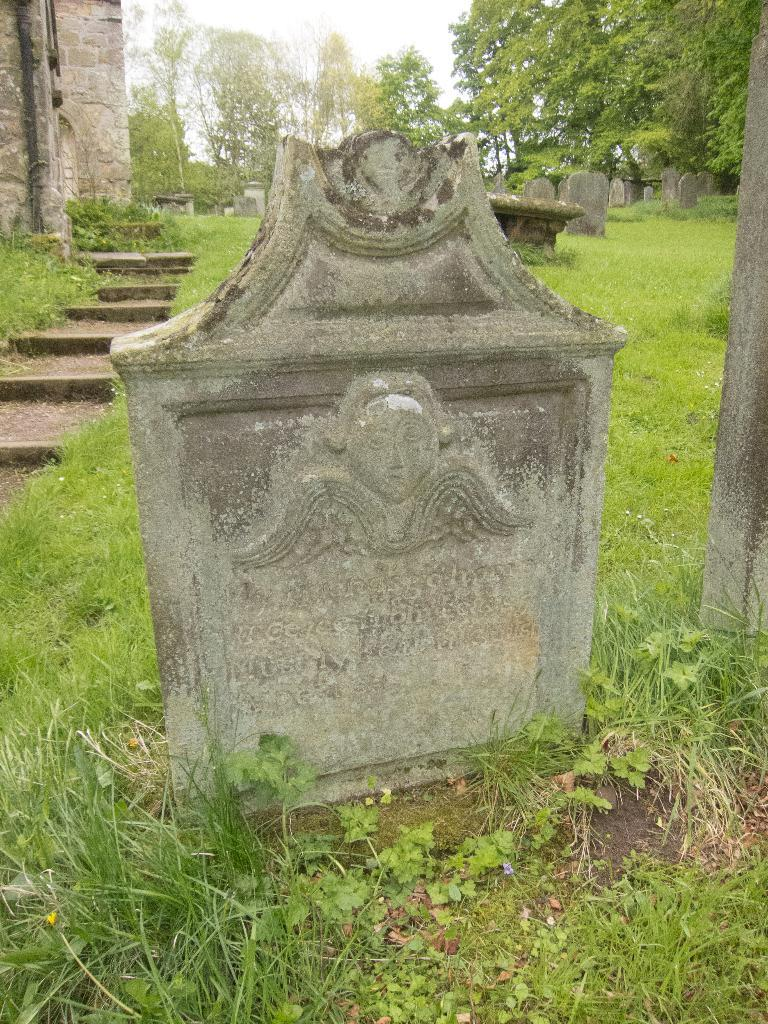What type of location is depicted in the image? The image contains cemeteries, which suggests a solemn or memorial location. What type of vegetation can be seen in the image? There is grass visible in the image, as well as trees. What type of structure is present in the image? There is a building in the image. What part of the natural environment is visible in the image? The sky is visible in the image. Can you determine the time of day the image was taken? The image was likely taken during the day, as the sky is visible and not dark. What type of wilderness can be seen in the image? There is no wilderness present in the image; it features cemeteries, grass, trees, a building, and the sky. What emotion is the person in the image experiencing? There is no person present in the image, so it is impossible to determine their emotions. 